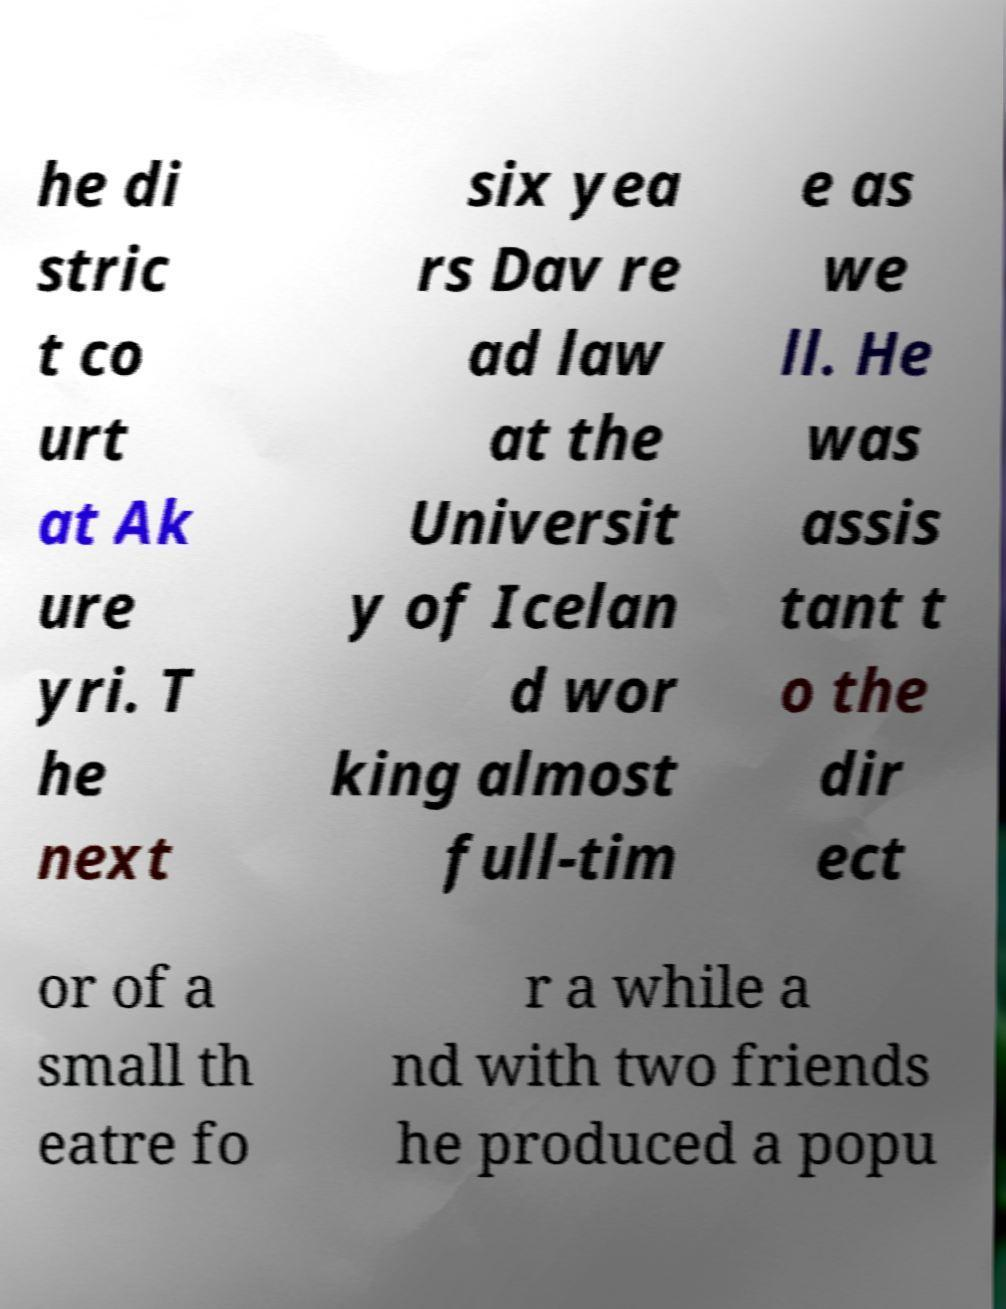For documentation purposes, I need the text within this image transcribed. Could you provide that? he di stric t co urt at Ak ure yri. T he next six yea rs Dav re ad law at the Universit y of Icelan d wor king almost full-tim e as we ll. He was assis tant t o the dir ect or of a small th eatre fo r a while a nd with two friends he produced a popu 